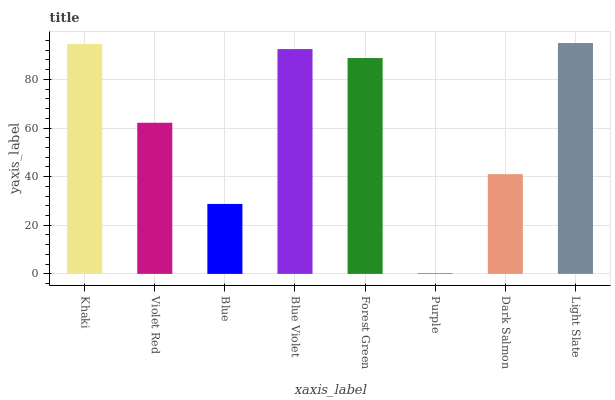Is Purple the minimum?
Answer yes or no. Yes. Is Light Slate the maximum?
Answer yes or no. Yes. Is Violet Red the minimum?
Answer yes or no. No. Is Violet Red the maximum?
Answer yes or no. No. Is Khaki greater than Violet Red?
Answer yes or no. Yes. Is Violet Red less than Khaki?
Answer yes or no. Yes. Is Violet Red greater than Khaki?
Answer yes or no. No. Is Khaki less than Violet Red?
Answer yes or no. No. Is Forest Green the high median?
Answer yes or no. Yes. Is Violet Red the low median?
Answer yes or no. Yes. Is Blue Violet the high median?
Answer yes or no. No. Is Forest Green the low median?
Answer yes or no. No. 